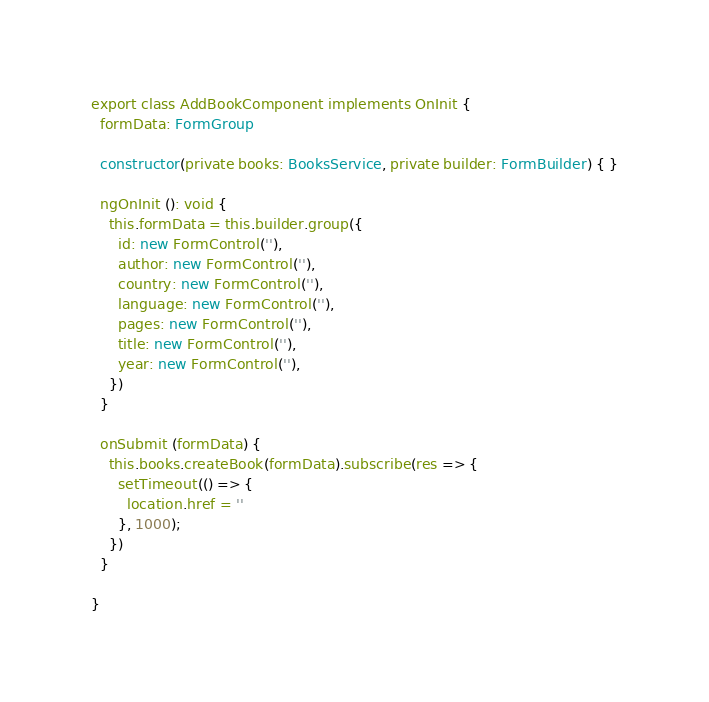<code> <loc_0><loc_0><loc_500><loc_500><_TypeScript_>export class AddBookComponent implements OnInit {
  formData: FormGroup

  constructor(private books: BooksService, private builder: FormBuilder) { }

  ngOnInit (): void {
    this.formData = this.builder.group({
      id: new FormControl(''),
      author: new FormControl(''),
      country: new FormControl(''),
      language: new FormControl(''),
      pages: new FormControl(''),
      title: new FormControl(''),
      year: new FormControl(''),
    })
  }

  onSubmit (formData) {
    this.books.createBook(formData).subscribe(res => {
      setTimeout(() => {
        location.href = ''
      }, 1000);
    })
  }

}
</code> 